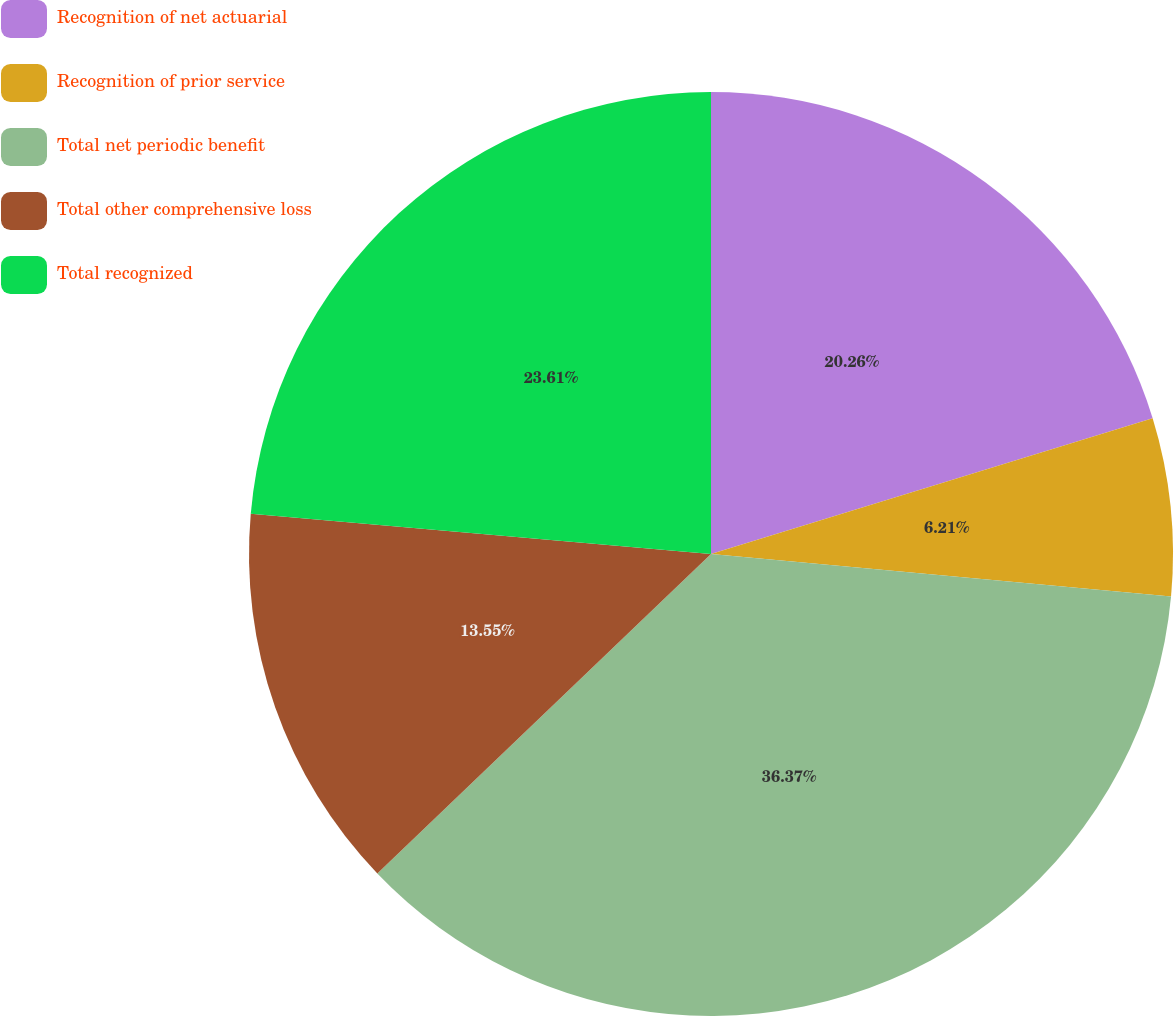Convert chart to OTSL. <chart><loc_0><loc_0><loc_500><loc_500><pie_chart><fcel>Recognition of net actuarial<fcel>Recognition of prior service<fcel>Total net periodic benefit<fcel>Total other comprehensive loss<fcel>Total recognized<nl><fcel>20.26%<fcel>6.21%<fcel>36.38%<fcel>13.55%<fcel>23.61%<nl></chart> 